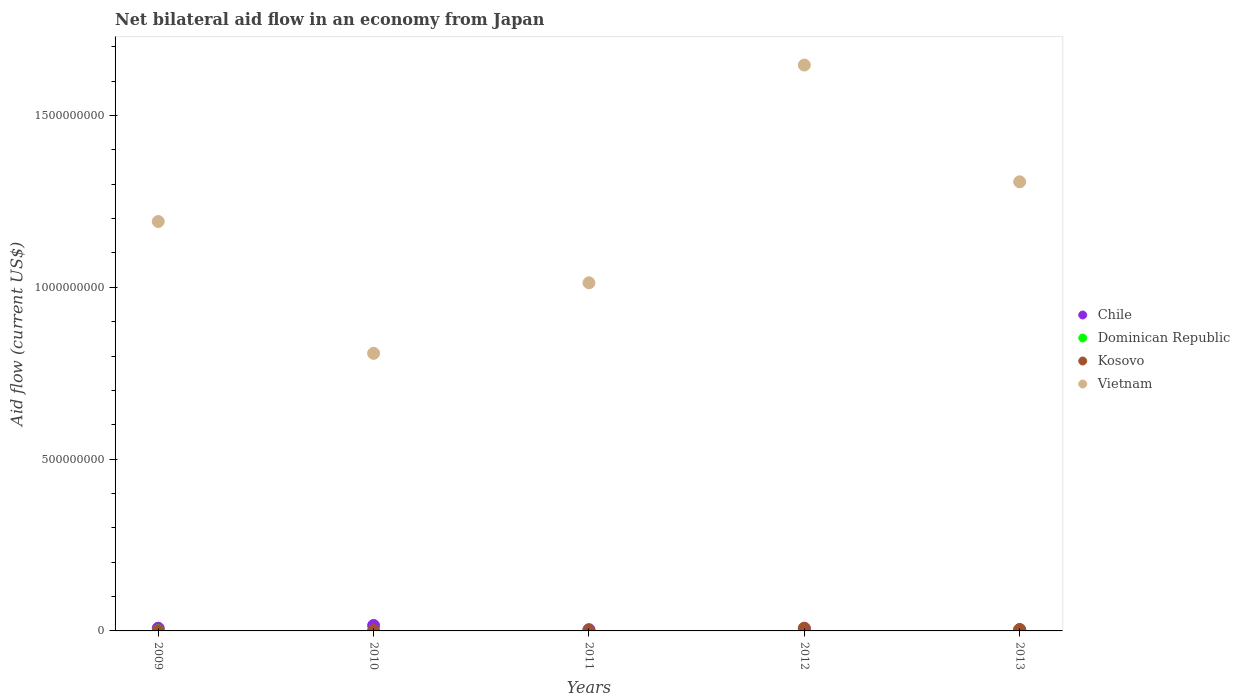How many different coloured dotlines are there?
Provide a short and direct response. 4. Is the number of dotlines equal to the number of legend labels?
Keep it short and to the point. No. What is the net bilateral aid flow in Vietnam in 2012?
Offer a terse response. 1.65e+09. Across all years, what is the maximum net bilateral aid flow in Kosovo?
Provide a short and direct response. 7.92e+06. What is the total net bilateral aid flow in Vietnam in the graph?
Keep it short and to the point. 5.97e+09. What is the difference between the net bilateral aid flow in Kosovo in 2009 and that in 2011?
Give a very brief answer. -1.73e+06. What is the difference between the net bilateral aid flow in Dominican Republic in 2009 and the net bilateral aid flow in Vietnam in 2012?
Ensure brevity in your answer.  -1.65e+09. What is the average net bilateral aid flow in Vietnam per year?
Offer a terse response. 1.19e+09. In the year 2013, what is the difference between the net bilateral aid flow in Kosovo and net bilateral aid flow in Dominican Republic?
Your answer should be compact. 2.91e+06. In how many years, is the net bilateral aid flow in Chile greater than 300000000 US$?
Offer a terse response. 0. What is the ratio of the net bilateral aid flow in Chile in 2009 to that in 2012?
Your answer should be very brief. 1.26. Is the net bilateral aid flow in Kosovo in 2011 less than that in 2012?
Make the answer very short. Yes. Is the difference between the net bilateral aid flow in Kosovo in 2009 and 2013 greater than the difference between the net bilateral aid flow in Dominican Republic in 2009 and 2013?
Your answer should be compact. No. What is the difference between the highest and the second highest net bilateral aid flow in Chile?
Your response must be concise. 8.01e+06. What is the difference between the highest and the lowest net bilateral aid flow in Dominican Republic?
Ensure brevity in your answer.  9.50e+05. In how many years, is the net bilateral aid flow in Vietnam greater than the average net bilateral aid flow in Vietnam taken over all years?
Keep it short and to the point. 2. Is it the case that in every year, the sum of the net bilateral aid flow in Dominican Republic and net bilateral aid flow in Vietnam  is greater than the sum of net bilateral aid flow in Chile and net bilateral aid flow in Kosovo?
Give a very brief answer. Yes. Is the net bilateral aid flow in Vietnam strictly greater than the net bilateral aid flow in Chile over the years?
Give a very brief answer. Yes. Is the net bilateral aid flow in Vietnam strictly less than the net bilateral aid flow in Kosovo over the years?
Your answer should be very brief. No. How many dotlines are there?
Your answer should be compact. 4. How many years are there in the graph?
Provide a short and direct response. 5. Are the values on the major ticks of Y-axis written in scientific E-notation?
Ensure brevity in your answer.  No. Does the graph contain any zero values?
Give a very brief answer. Yes. Where does the legend appear in the graph?
Give a very brief answer. Center right. What is the title of the graph?
Provide a succinct answer. Net bilateral aid flow in an economy from Japan. Does "Cayman Islands" appear as one of the legend labels in the graph?
Your answer should be compact. No. What is the label or title of the X-axis?
Make the answer very short. Years. What is the Aid flow (current US$) in Chile in 2009?
Provide a succinct answer. 7.90e+06. What is the Aid flow (current US$) in Vietnam in 2009?
Your response must be concise. 1.19e+09. What is the Aid flow (current US$) in Chile in 2010?
Offer a terse response. 1.59e+07. What is the Aid flow (current US$) of Dominican Republic in 2010?
Your response must be concise. 0. What is the Aid flow (current US$) of Kosovo in 2010?
Give a very brief answer. 1.08e+06. What is the Aid flow (current US$) in Vietnam in 2010?
Offer a terse response. 8.08e+08. What is the Aid flow (current US$) of Chile in 2011?
Ensure brevity in your answer.  3.64e+06. What is the Aid flow (current US$) of Dominican Republic in 2011?
Ensure brevity in your answer.  0. What is the Aid flow (current US$) of Kosovo in 2011?
Keep it short and to the point. 1.88e+06. What is the Aid flow (current US$) in Vietnam in 2011?
Give a very brief answer. 1.01e+09. What is the Aid flow (current US$) of Chile in 2012?
Provide a succinct answer. 6.25e+06. What is the Aid flow (current US$) in Dominican Republic in 2012?
Keep it short and to the point. 0. What is the Aid flow (current US$) in Kosovo in 2012?
Your response must be concise. 7.92e+06. What is the Aid flow (current US$) of Vietnam in 2012?
Give a very brief answer. 1.65e+09. What is the Aid flow (current US$) of Chile in 2013?
Keep it short and to the point. 3.62e+06. What is the Aid flow (current US$) of Dominican Republic in 2013?
Provide a succinct answer. 9.50e+05. What is the Aid flow (current US$) of Kosovo in 2013?
Give a very brief answer. 3.86e+06. What is the Aid flow (current US$) of Vietnam in 2013?
Your response must be concise. 1.31e+09. Across all years, what is the maximum Aid flow (current US$) in Chile?
Your answer should be very brief. 1.59e+07. Across all years, what is the maximum Aid flow (current US$) in Dominican Republic?
Your answer should be very brief. 9.50e+05. Across all years, what is the maximum Aid flow (current US$) in Kosovo?
Provide a succinct answer. 7.92e+06. Across all years, what is the maximum Aid flow (current US$) of Vietnam?
Your answer should be compact. 1.65e+09. Across all years, what is the minimum Aid flow (current US$) in Chile?
Offer a very short reply. 3.62e+06. Across all years, what is the minimum Aid flow (current US$) of Dominican Republic?
Offer a very short reply. 0. Across all years, what is the minimum Aid flow (current US$) of Kosovo?
Make the answer very short. 1.50e+05. Across all years, what is the minimum Aid flow (current US$) of Vietnam?
Your response must be concise. 8.08e+08. What is the total Aid flow (current US$) of Chile in the graph?
Give a very brief answer. 3.73e+07. What is the total Aid flow (current US$) of Dominican Republic in the graph?
Offer a terse response. 1.18e+06. What is the total Aid flow (current US$) of Kosovo in the graph?
Make the answer very short. 1.49e+07. What is the total Aid flow (current US$) in Vietnam in the graph?
Your answer should be very brief. 5.97e+09. What is the difference between the Aid flow (current US$) of Chile in 2009 and that in 2010?
Keep it short and to the point. -8.01e+06. What is the difference between the Aid flow (current US$) in Kosovo in 2009 and that in 2010?
Your answer should be very brief. -9.30e+05. What is the difference between the Aid flow (current US$) in Vietnam in 2009 and that in 2010?
Offer a very short reply. 3.84e+08. What is the difference between the Aid flow (current US$) in Chile in 2009 and that in 2011?
Make the answer very short. 4.26e+06. What is the difference between the Aid flow (current US$) of Kosovo in 2009 and that in 2011?
Make the answer very short. -1.73e+06. What is the difference between the Aid flow (current US$) in Vietnam in 2009 and that in 2011?
Make the answer very short. 1.78e+08. What is the difference between the Aid flow (current US$) in Chile in 2009 and that in 2012?
Give a very brief answer. 1.65e+06. What is the difference between the Aid flow (current US$) of Kosovo in 2009 and that in 2012?
Provide a succinct answer. -7.77e+06. What is the difference between the Aid flow (current US$) of Vietnam in 2009 and that in 2012?
Give a very brief answer. -4.55e+08. What is the difference between the Aid flow (current US$) of Chile in 2009 and that in 2013?
Give a very brief answer. 4.28e+06. What is the difference between the Aid flow (current US$) in Dominican Republic in 2009 and that in 2013?
Your response must be concise. -7.20e+05. What is the difference between the Aid flow (current US$) of Kosovo in 2009 and that in 2013?
Keep it short and to the point. -3.71e+06. What is the difference between the Aid flow (current US$) in Vietnam in 2009 and that in 2013?
Make the answer very short. -1.16e+08. What is the difference between the Aid flow (current US$) of Chile in 2010 and that in 2011?
Your answer should be very brief. 1.23e+07. What is the difference between the Aid flow (current US$) of Kosovo in 2010 and that in 2011?
Ensure brevity in your answer.  -8.00e+05. What is the difference between the Aid flow (current US$) in Vietnam in 2010 and that in 2011?
Make the answer very short. -2.05e+08. What is the difference between the Aid flow (current US$) in Chile in 2010 and that in 2012?
Offer a very short reply. 9.66e+06. What is the difference between the Aid flow (current US$) in Kosovo in 2010 and that in 2012?
Offer a terse response. -6.84e+06. What is the difference between the Aid flow (current US$) of Vietnam in 2010 and that in 2012?
Give a very brief answer. -8.39e+08. What is the difference between the Aid flow (current US$) of Chile in 2010 and that in 2013?
Provide a short and direct response. 1.23e+07. What is the difference between the Aid flow (current US$) in Kosovo in 2010 and that in 2013?
Your answer should be very brief. -2.78e+06. What is the difference between the Aid flow (current US$) of Vietnam in 2010 and that in 2013?
Your answer should be very brief. -4.99e+08. What is the difference between the Aid flow (current US$) in Chile in 2011 and that in 2012?
Your answer should be very brief. -2.61e+06. What is the difference between the Aid flow (current US$) of Kosovo in 2011 and that in 2012?
Your response must be concise. -6.04e+06. What is the difference between the Aid flow (current US$) of Vietnam in 2011 and that in 2012?
Offer a terse response. -6.34e+08. What is the difference between the Aid flow (current US$) in Chile in 2011 and that in 2013?
Give a very brief answer. 2.00e+04. What is the difference between the Aid flow (current US$) in Kosovo in 2011 and that in 2013?
Your answer should be very brief. -1.98e+06. What is the difference between the Aid flow (current US$) of Vietnam in 2011 and that in 2013?
Make the answer very short. -2.94e+08. What is the difference between the Aid flow (current US$) of Chile in 2012 and that in 2013?
Offer a terse response. 2.63e+06. What is the difference between the Aid flow (current US$) in Kosovo in 2012 and that in 2013?
Offer a terse response. 4.06e+06. What is the difference between the Aid flow (current US$) in Vietnam in 2012 and that in 2013?
Keep it short and to the point. 3.40e+08. What is the difference between the Aid flow (current US$) in Chile in 2009 and the Aid flow (current US$) in Kosovo in 2010?
Your answer should be very brief. 6.82e+06. What is the difference between the Aid flow (current US$) of Chile in 2009 and the Aid flow (current US$) of Vietnam in 2010?
Make the answer very short. -8.00e+08. What is the difference between the Aid flow (current US$) of Dominican Republic in 2009 and the Aid flow (current US$) of Kosovo in 2010?
Offer a very short reply. -8.50e+05. What is the difference between the Aid flow (current US$) of Dominican Republic in 2009 and the Aid flow (current US$) of Vietnam in 2010?
Provide a short and direct response. -8.08e+08. What is the difference between the Aid flow (current US$) of Kosovo in 2009 and the Aid flow (current US$) of Vietnam in 2010?
Provide a short and direct response. -8.08e+08. What is the difference between the Aid flow (current US$) of Chile in 2009 and the Aid flow (current US$) of Kosovo in 2011?
Provide a short and direct response. 6.02e+06. What is the difference between the Aid flow (current US$) in Chile in 2009 and the Aid flow (current US$) in Vietnam in 2011?
Give a very brief answer. -1.01e+09. What is the difference between the Aid flow (current US$) of Dominican Republic in 2009 and the Aid flow (current US$) of Kosovo in 2011?
Ensure brevity in your answer.  -1.65e+06. What is the difference between the Aid flow (current US$) of Dominican Republic in 2009 and the Aid flow (current US$) of Vietnam in 2011?
Offer a terse response. -1.01e+09. What is the difference between the Aid flow (current US$) in Kosovo in 2009 and the Aid flow (current US$) in Vietnam in 2011?
Make the answer very short. -1.01e+09. What is the difference between the Aid flow (current US$) of Chile in 2009 and the Aid flow (current US$) of Vietnam in 2012?
Provide a succinct answer. -1.64e+09. What is the difference between the Aid flow (current US$) in Dominican Republic in 2009 and the Aid flow (current US$) in Kosovo in 2012?
Offer a terse response. -7.69e+06. What is the difference between the Aid flow (current US$) in Dominican Republic in 2009 and the Aid flow (current US$) in Vietnam in 2012?
Your response must be concise. -1.65e+09. What is the difference between the Aid flow (current US$) of Kosovo in 2009 and the Aid flow (current US$) of Vietnam in 2012?
Your response must be concise. -1.65e+09. What is the difference between the Aid flow (current US$) of Chile in 2009 and the Aid flow (current US$) of Dominican Republic in 2013?
Offer a terse response. 6.95e+06. What is the difference between the Aid flow (current US$) in Chile in 2009 and the Aid flow (current US$) in Kosovo in 2013?
Give a very brief answer. 4.04e+06. What is the difference between the Aid flow (current US$) of Chile in 2009 and the Aid flow (current US$) of Vietnam in 2013?
Keep it short and to the point. -1.30e+09. What is the difference between the Aid flow (current US$) of Dominican Republic in 2009 and the Aid flow (current US$) of Kosovo in 2013?
Provide a short and direct response. -3.63e+06. What is the difference between the Aid flow (current US$) of Dominican Republic in 2009 and the Aid flow (current US$) of Vietnam in 2013?
Your answer should be very brief. -1.31e+09. What is the difference between the Aid flow (current US$) in Kosovo in 2009 and the Aid flow (current US$) in Vietnam in 2013?
Your answer should be very brief. -1.31e+09. What is the difference between the Aid flow (current US$) of Chile in 2010 and the Aid flow (current US$) of Kosovo in 2011?
Make the answer very short. 1.40e+07. What is the difference between the Aid flow (current US$) in Chile in 2010 and the Aid flow (current US$) in Vietnam in 2011?
Provide a succinct answer. -9.97e+08. What is the difference between the Aid flow (current US$) in Kosovo in 2010 and the Aid flow (current US$) in Vietnam in 2011?
Offer a terse response. -1.01e+09. What is the difference between the Aid flow (current US$) of Chile in 2010 and the Aid flow (current US$) of Kosovo in 2012?
Ensure brevity in your answer.  7.99e+06. What is the difference between the Aid flow (current US$) in Chile in 2010 and the Aid flow (current US$) in Vietnam in 2012?
Keep it short and to the point. -1.63e+09. What is the difference between the Aid flow (current US$) in Kosovo in 2010 and the Aid flow (current US$) in Vietnam in 2012?
Provide a short and direct response. -1.65e+09. What is the difference between the Aid flow (current US$) of Chile in 2010 and the Aid flow (current US$) of Dominican Republic in 2013?
Give a very brief answer. 1.50e+07. What is the difference between the Aid flow (current US$) in Chile in 2010 and the Aid flow (current US$) in Kosovo in 2013?
Your response must be concise. 1.20e+07. What is the difference between the Aid flow (current US$) of Chile in 2010 and the Aid flow (current US$) of Vietnam in 2013?
Offer a terse response. -1.29e+09. What is the difference between the Aid flow (current US$) of Kosovo in 2010 and the Aid flow (current US$) of Vietnam in 2013?
Provide a succinct answer. -1.31e+09. What is the difference between the Aid flow (current US$) in Chile in 2011 and the Aid flow (current US$) in Kosovo in 2012?
Ensure brevity in your answer.  -4.28e+06. What is the difference between the Aid flow (current US$) in Chile in 2011 and the Aid flow (current US$) in Vietnam in 2012?
Make the answer very short. -1.64e+09. What is the difference between the Aid flow (current US$) in Kosovo in 2011 and the Aid flow (current US$) in Vietnam in 2012?
Keep it short and to the point. -1.64e+09. What is the difference between the Aid flow (current US$) in Chile in 2011 and the Aid flow (current US$) in Dominican Republic in 2013?
Offer a very short reply. 2.69e+06. What is the difference between the Aid flow (current US$) in Chile in 2011 and the Aid flow (current US$) in Kosovo in 2013?
Your answer should be compact. -2.20e+05. What is the difference between the Aid flow (current US$) in Chile in 2011 and the Aid flow (current US$) in Vietnam in 2013?
Offer a very short reply. -1.30e+09. What is the difference between the Aid flow (current US$) of Kosovo in 2011 and the Aid flow (current US$) of Vietnam in 2013?
Make the answer very short. -1.31e+09. What is the difference between the Aid flow (current US$) in Chile in 2012 and the Aid flow (current US$) in Dominican Republic in 2013?
Your answer should be very brief. 5.30e+06. What is the difference between the Aid flow (current US$) in Chile in 2012 and the Aid flow (current US$) in Kosovo in 2013?
Offer a terse response. 2.39e+06. What is the difference between the Aid flow (current US$) of Chile in 2012 and the Aid flow (current US$) of Vietnam in 2013?
Ensure brevity in your answer.  -1.30e+09. What is the difference between the Aid flow (current US$) of Kosovo in 2012 and the Aid flow (current US$) of Vietnam in 2013?
Make the answer very short. -1.30e+09. What is the average Aid flow (current US$) in Chile per year?
Ensure brevity in your answer.  7.46e+06. What is the average Aid flow (current US$) of Dominican Republic per year?
Your answer should be very brief. 2.36e+05. What is the average Aid flow (current US$) in Kosovo per year?
Offer a terse response. 2.98e+06. What is the average Aid flow (current US$) of Vietnam per year?
Your answer should be very brief. 1.19e+09. In the year 2009, what is the difference between the Aid flow (current US$) in Chile and Aid flow (current US$) in Dominican Republic?
Give a very brief answer. 7.67e+06. In the year 2009, what is the difference between the Aid flow (current US$) in Chile and Aid flow (current US$) in Kosovo?
Your response must be concise. 7.75e+06. In the year 2009, what is the difference between the Aid flow (current US$) in Chile and Aid flow (current US$) in Vietnam?
Ensure brevity in your answer.  -1.18e+09. In the year 2009, what is the difference between the Aid flow (current US$) of Dominican Republic and Aid flow (current US$) of Kosovo?
Give a very brief answer. 8.00e+04. In the year 2009, what is the difference between the Aid flow (current US$) of Dominican Republic and Aid flow (current US$) of Vietnam?
Your response must be concise. -1.19e+09. In the year 2009, what is the difference between the Aid flow (current US$) in Kosovo and Aid flow (current US$) in Vietnam?
Provide a short and direct response. -1.19e+09. In the year 2010, what is the difference between the Aid flow (current US$) in Chile and Aid flow (current US$) in Kosovo?
Your answer should be compact. 1.48e+07. In the year 2010, what is the difference between the Aid flow (current US$) in Chile and Aid flow (current US$) in Vietnam?
Your answer should be compact. -7.92e+08. In the year 2010, what is the difference between the Aid flow (current US$) of Kosovo and Aid flow (current US$) of Vietnam?
Your response must be concise. -8.07e+08. In the year 2011, what is the difference between the Aid flow (current US$) of Chile and Aid flow (current US$) of Kosovo?
Your answer should be compact. 1.76e+06. In the year 2011, what is the difference between the Aid flow (current US$) in Chile and Aid flow (current US$) in Vietnam?
Give a very brief answer. -1.01e+09. In the year 2011, what is the difference between the Aid flow (current US$) of Kosovo and Aid flow (current US$) of Vietnam?
Give a very brief answer. -1.01e+09. In the year 2012, what is the difference between the Aid flow (current US$) of Chile and Aid flow (current US$) of Kosovo?
Give a very brief answer. -1.67e+06. In the year 2012, what is the difference between the Aid flow (current US$) in Chile and Aid flow (current US$) in Vietnam?
Your answer should be very brief. -1.64e+09. In the year 2012, what is the difference between the Aid flow (current US$) in Kosovo and Aid flow (current US$) in Vietnam?
Keep it short and to the point. -1.64e+09. In the year 2013, what is the difference between the Aid flow (current US$) of Chile and Aid flow (current US$) of Dominican Republic?
Offer a terse response. 2.67e+06. In the year 2013, what is the difference between the Aid flow (current US$) of Chile and Aid flow (current US$) of Vietnam?
Your answer should be very brief. -1.30e+09. In the year 2013, what is the difference between the Aid flow (current US$) of Dominican Republic and Aid flow (current US$) of Kosovo?
Your answer should be compact. -2.91e+06. In the year 2013, what is the difference between the Aid flow (current US$) of Dominican Republic and Aid flow (current US$) of Vietnam?
Your response must be concise. -1.31e+09. In the year 2013, what is the difference between the Aid flow (current US$) in Kosovo and Aid flow (current US$) in Vietnam?
Offer a terse response. -1.30e+09. What is the ratio of the Aid flow (current US$) in Chile in 2009 to that in 2010?
Make the answer very short. 0.5. What is the ratio of the Aid flow (current US$) of Kosovo in 2009 to that in 2010?
Your response must be concise. 0.14. What is the ratio of the Aid flow (current US$) of Vietnam in 2009 to that in 2010?
Ensure brevity in your answer.  1.47. What is the ratio of the Aid flow (current US$) in Chile in 2009 to that in 2011?
Provide a succinct answer. 2.17. What is the ratio of the Aid flow (current US$) of Kosovo in 2009 to that in 2011?
Provide a succinct answer. 0.08. What is the ratio of the Aid flow (current US$) in Vietnam in 2009 to that in 2011?
Make the answer very short. 1.18. What is the ratio of the Aid flow (current US$) in Chile in 2009 to that in 2012?
Your response must be concise. 1.26. What is the ratio of the Aid flow (current US$) of Kosovo in 2009 to that in 2012?
Offer a terse response. 0.02. What is the ratio of the Aid flow (current US$) of Vietnam in 2009 to that in 2012?
Provide a succinct answer. 0.72. What is the ratio of the Aid flow (current US$) of Chile in 2009 to that in 2013?
Ensure brevity in your answer.  2.18. What is the ratio of the Aid flow (current US$) of Dominican Republic in 2009 to that in 2013?
Your answer should be compact. 0.24. What is the ratio of the Aid flow (current US$) of Kosovo in 2009 to that in 2013?
Your answer should be very brief. 0.04. What is the ratio of the Aid flow (current US$) in Vietnam in 2009 to that in 2013?
Provide a short and direct response. 0.91. What is the ratio of the Aid flow (current US$) of Chile in 2010 to that in 2011?
Your response must be concise. 4.37. What is the ratio of the Aid flow (current US$) of Kosovo in 2010 to that in 2011?
Offer a very short reply. 0.57. What is the ratio of the Aid flow (current US$) of Vietnam in 2010 to that in 2011?
Provide a succinct answer. 0.8. What is the ratio of the Aid flow (current US$) of Chile in 2010 to that in 2012?
Offer a terse response. 2.55. What is the ratio of the Aid flow (current US$) in Kosovo in 2010 to that in 2012?
Ensure brevity in your answer.  0.14. What is the ratio of the Aid flow (current US$) of Vietnam in 2010 to that in 2012?
Offer a very short reply. 0.49. What is the ratio of the Aid flow (current US$) of Chile in 2010 to that in 2013?
Provide a short and direct response. 4.39. What is the ratio of the Aid flow (current US$) of Kosovo in 2010 to that in 2013?
Provide a short and direct response. 0.28. What is the ratio of the Aid flow (current US$) in Vietnam in 2010 to that in 2013?
Make the answer very short. 0.62. What is the ratio of the Aid flow (current US$) in Chile in 2011 to that in 2012?
Ensure brevity in your answer.  0.58. What is the ratio of the Aid flow (current US$) of Kosovo in 2011 to that in 2012?
Provide a succinct answer. 0.24. What is the ratio of the Aid flow (current US$) in Vietnam in 2011 to that in 2012?
Offer a very short reply. 0.62. What is the ratio of the Aid flow (current US$) in Chile in 2011 to that in 2013?
Provide a succinct answer. 1.01. What is the ratio of the Aid flow (current US$) of Kosovo in 2011 to that in 2013?
Make the answer very short. 0.49. What is the ratio of the Aid flow (current US$) of Vietnam in 2011 to that in 2013?
Offer a very short reply. 0.78. What is the ratio of the Aid flow (current US$) of Chile in 2012 to that in 2013?
Your response must be concise. 1.73. What is the ratio of the Aid flow (current US$) of Kosovo in 2012 to that in 2013?
Provide a succinct answer. 2.05. What is the ratio of the Aid flow (current US$) of Vietnam in 2012 to that in 2013?
Give a very brief answer. 1.26. What is the difference between the highest and the second highest Aid flow (current US$) of Chile?
Your answer should be compact. 8.01e+06. What is the difference between the highest and the second highest Aid flow (current US$) of Kosovo?
Your answer should be compact. 4.06e+06. What is the difference between the highest and the second highest Aid flow (current US$) of Vietnam?
Give a very brief answer. 3.40e+08. What is the difference between the highest and the lowest Aid flow (current US$) in Chile?
Your answer should be very brief. 1.23e+07. What is the difference between the highest and the lowest Aid flow (current US$) of Dominican Republic?
Ensure brevity in your answer.  9.50e+05. What is the difference between the highest and the lowest Aid flow (current US$) of Kosovo?
Offer a terse response. 7.77e+06. What is the difference between the highest and the lowest Aid flow (current US$) in Vietnam?
Keep it short and to the point. 8.39e+08. 